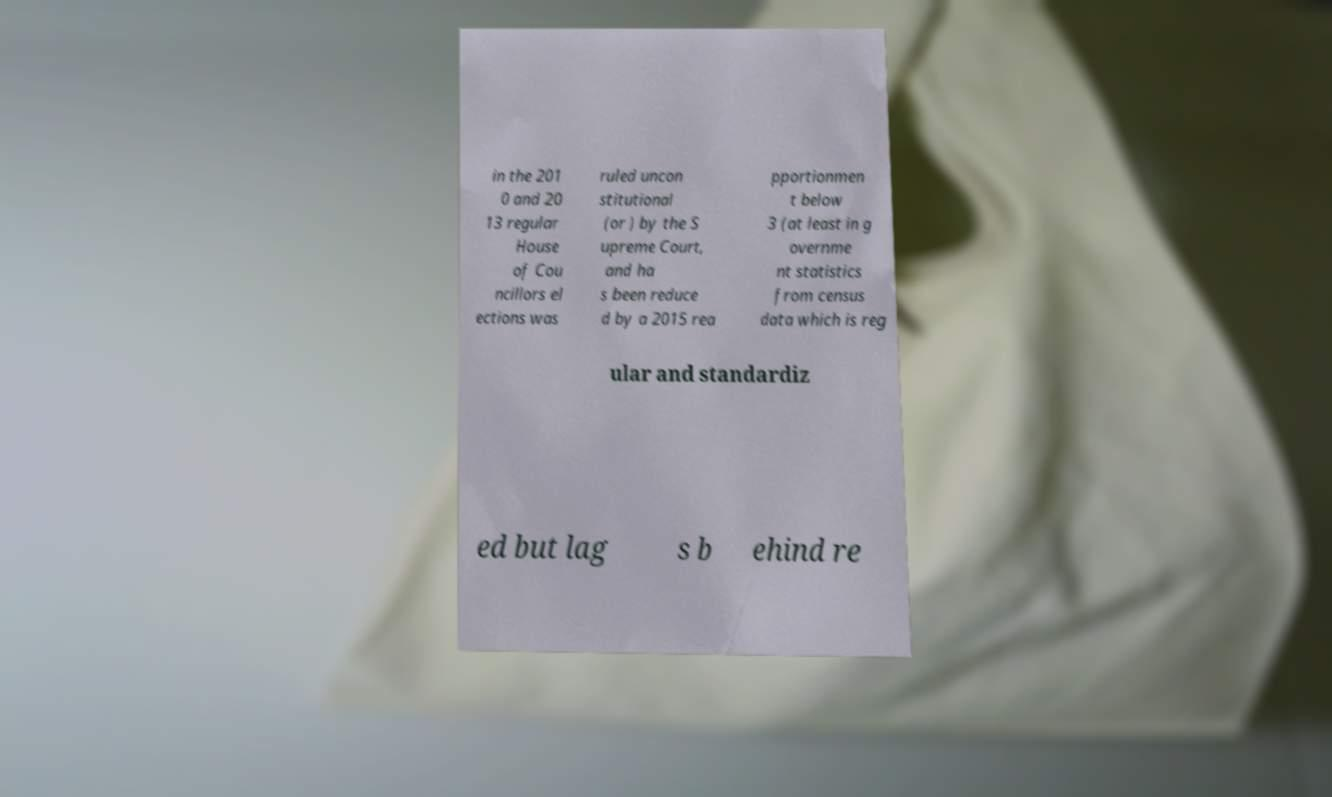Can you accurately transcribe the text from the provided image for me? in the 201 0 and 20 13 regular House of Cou ncillors el ections was ruled uncon stitutional (or ) by the S upreme Court, and ha s been reduce d by a 2015 rea pportionmen t below 3 (at least in g overnme nt statistics from census data which is reg ular and standardiz ed but lag s b ehind re 